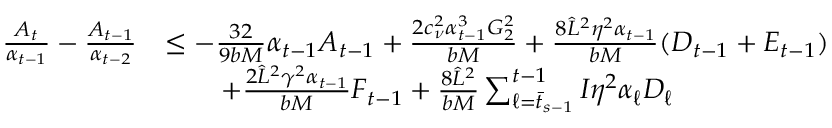<formula> <loc_0><loc_0><loc_500><loc_500>\begin{array} { r l } { \frac { A _ { t } } { \alpha _ { t - 1 } } - \frac { A _ { t - 1 } } { \alpha _ { t - 2 } } } & { \leq - \frac { 3 2 } { 9 b M } \alpha _ { t - 1 } A _ { t - 1 } + \frac { 2 c _ { \nu } ^ { 2 } \alpha _ { t - 1 } ^ { 3 } G _ { 2 } ^ { 2 } } { b M } + \frac { 8 \hat { L } ^ { 2 } \eta ^ { 2 } \alpha _ { t - 1 } } { b M } ( D _ { t - 1 } + E _ { t - 1 } ) } \\ & { \quad + \frac { 2 \hat { L } ^ { 2 } \gamma ^ { 2 } \alpha _ { t - 1 } } { b M } F _ { t - 1 } + \frac { 8 \hat { L } ^ { 2 } } { b M } \sum _ { \ell = \bar { t } _ { s - 1 } } ^ { t - 1 } I \eta ^ { 2 } \alpha _ { \ell } D _ { \ell } } \end{array}</formula> 